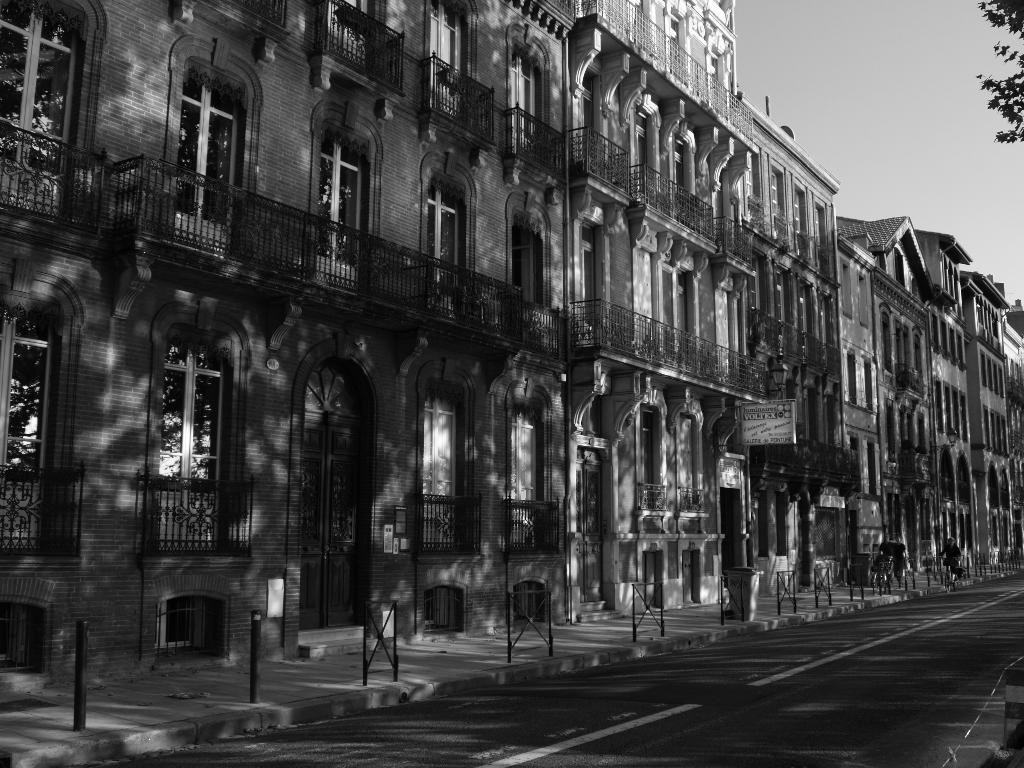What type of structures can be seen in the image? There are buildings in the image. How many windows are visible in the image? There are multiple windows visible in the image. What else can be seen in the image besides buildings and windows? There are poles and leaves of a tree present in the image. What is the condition of the road in the image? There are lines on the road in the image. What is the color scheme of the image? The image is black and white in color. Where is the cellar located in the image? There is no cellar present in the image. What type of carriage can be seen traveling on the road in the image? There is no carriage present in the image; the image is black and white and does not depict any vehicles. 